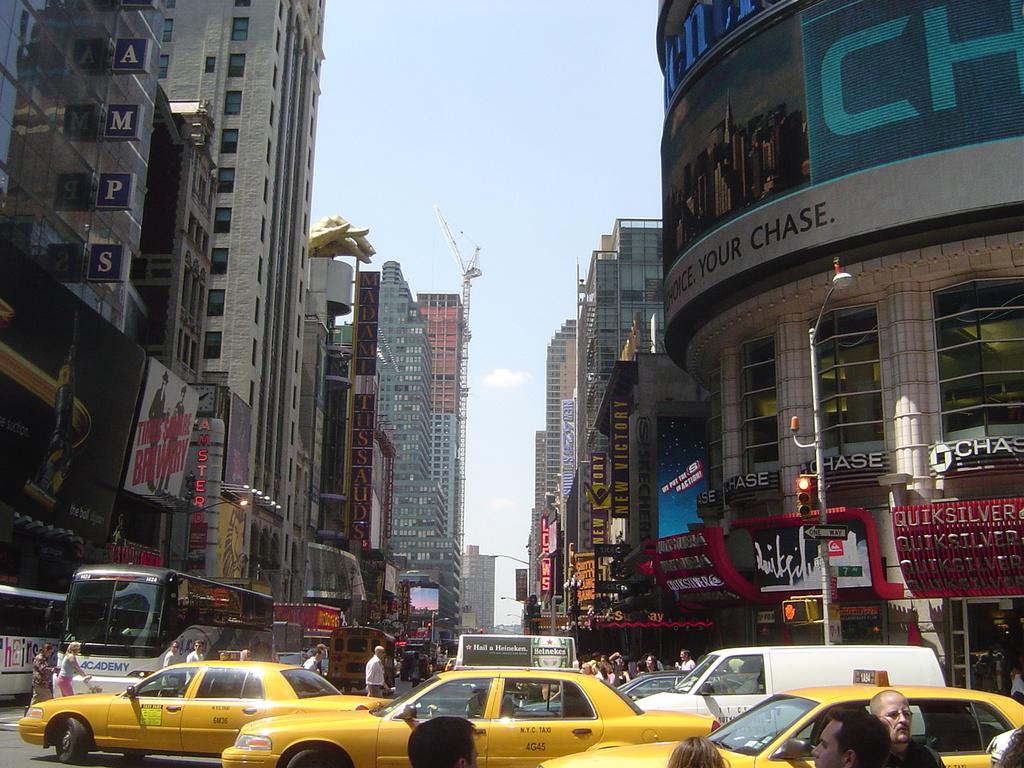What is the name of the bank on the building on the right?
Make the answer very short. Chase. What brand is advertised on top of the taxicab in the center?
Your response must be concise. Heineken. 